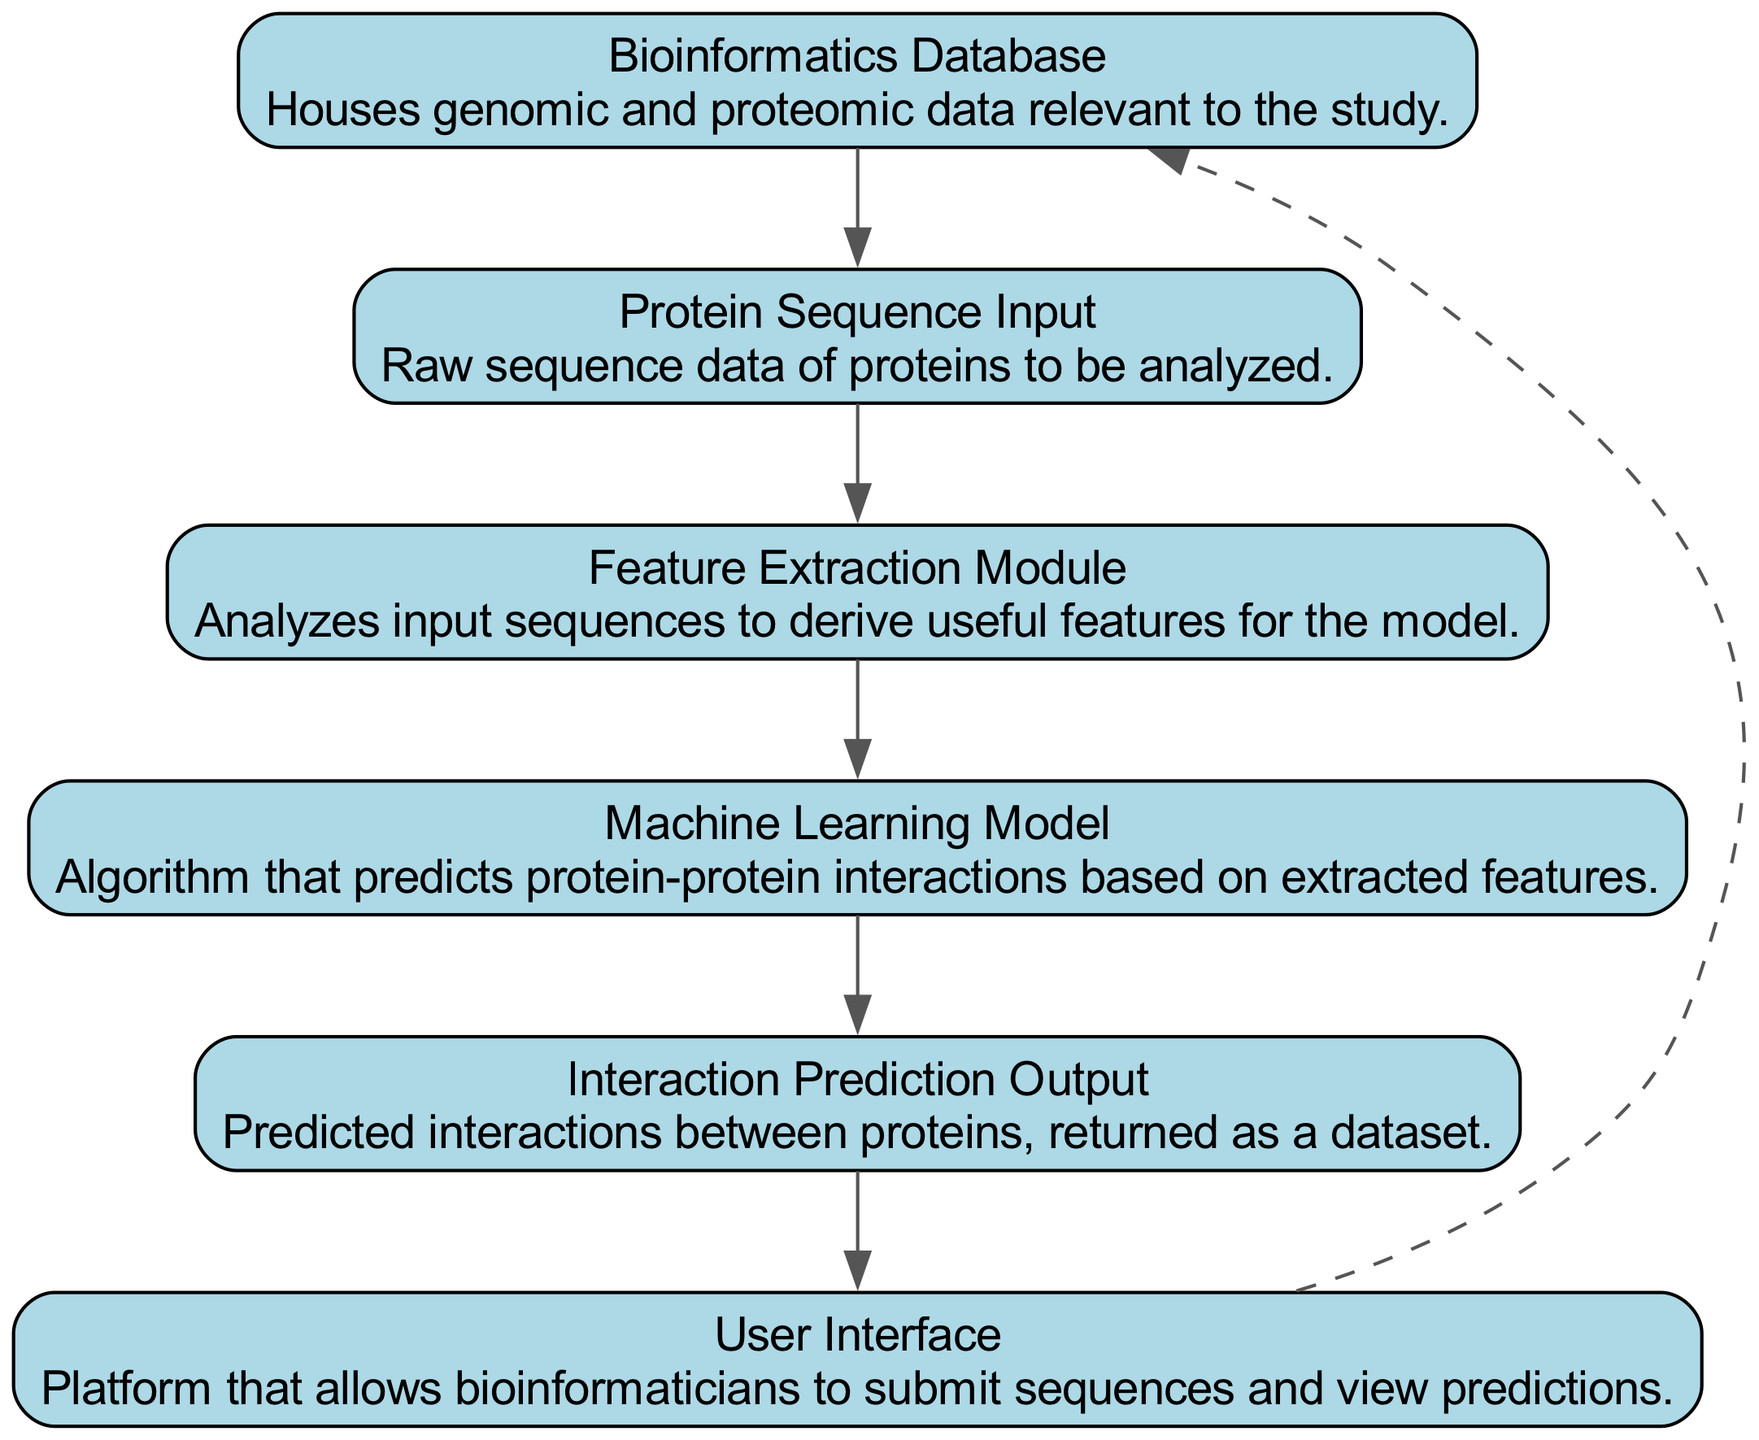What is the first node in the sequence diagram? The first node listed in the diagram is "Bioinformatics Database," which is the starting point for input sequences based on genomic and proteomic data.
Answer: Bioinformatics Database How many nodes are present in the diagram? By counting each distinct entity listed, there are six nodes: Bioinformatics Database, Protein Sequence Input, Feature Extraction Module, Machine Learning Model, Interaction Prediction Output, and User Interface.
Answer: 6 What is the last node in the interaction sequence? Tracing the sequence from beginning to end, the last node in the diagram is "User Interface," which outputs the interaction predictions to the user.
Answer: User Interface Which module is responsible for deriving features from the protein sequences? It is indicated that the "Feature Extraction Module" is tasked with analyzing the input sequences to extract relevant features for the following machine learning model, thus serving this purpose specifically.
Answer: Feature Extraction Module What type of edge connects the User Interface to the Bioinformatics Database? In the diagram, the edge between the "User Interface" and the "Bioinformatics Database" is dashed, indicating a different relationship compared to the solid edges; it signifies a non-constraint or alternative flow.
Answer: Dashed Which component receives the raw sequence data for analysis? The arrow from "Protein Sequence Input" indicates that this component receives the raw protein sequence data for subsequent analysis in the feature extraction process.
Answer: Protein Sequence Input How does the interaction prediction move from the Machine Learning Model? The flow indicates that the "Machine Learning Model" directs its output, specifically the predicted interactions, to the "Interaction Prediction Output," establishing a direct link in the sequence.
Answer: Interaction Prediction Output What connects the Feature Extraction Module to the Machine Learning Model? The connection between these two components is a solid arrow, suggesting a direct flow of information and processing from the feature extraction to the machine learning model.
Answer: Solid edge What is the primary output of the Machine Learning Model? The output indicated by the diagram is "Interaction Prediction Output," which refers to the dataset containing the predicted interactions between proteins based on the analyzed features.
Answer: Interaction Prediction Output 